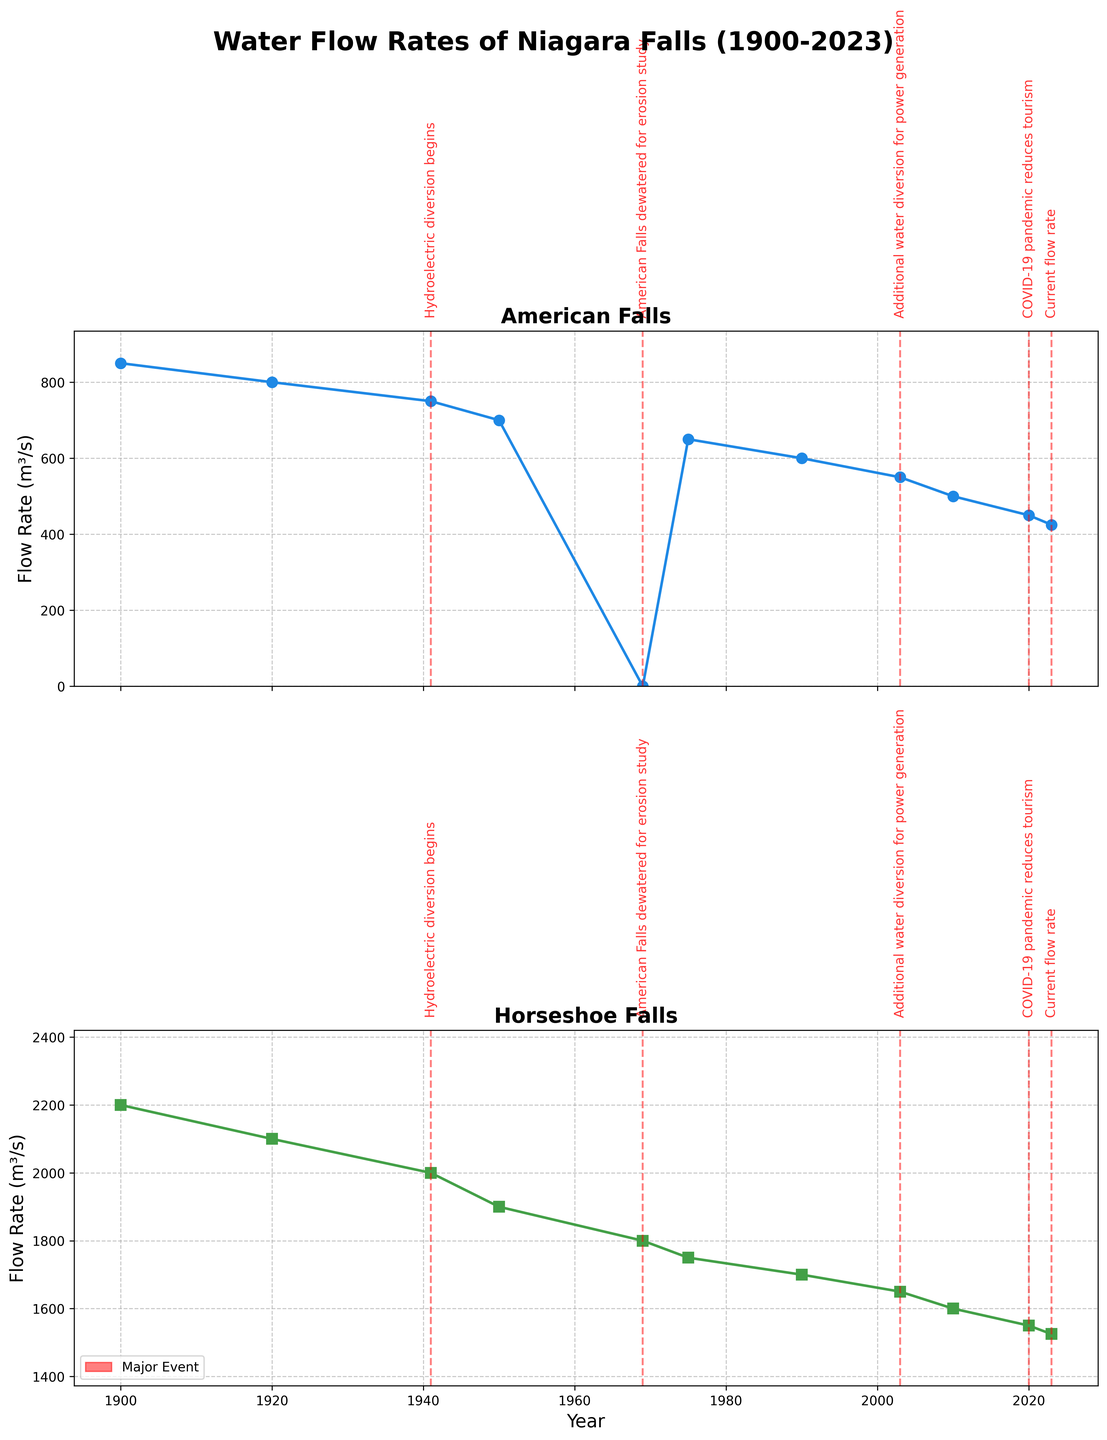What is the title of the figure? The title is usually found at the top of the figure. In this case, it's "Water Flow Rates of Niagara Falls (1900-2023)"
Answer: Water Flow Rates of Niagara Falls (1900-2023) Around what year did the American Falls have the lowest flow rate? Observing the plot for the American Falls, the lowest flow rate appears around the years 1969 and 2023, specifically during the "American Falls dewatered for erosion study" event in 1969 with a flow rate of 0 m³/s.
Answer: 1969 How many events are marked on the plots? Count the number of vertical red dashed lines on both subplots. These indicate events. There are 4 events marked.
Answer: 4 What event occurred in 1969, and how is it visually represented in the plots? In 1969, the "American Falls dewatered for erosion study" event occurred. It is represented by a vertical red dashed line and an annotation on the plot.
Answer: American Falls dewatered for erosion study Compare the flow rates of the American Falls and Horseshoe Falls in 2023. Locate the year 2023 on both plots, and compare the flow rates indicated for both falls. The American Falls has a flow rate of 425 m³/s, and the Horseshoe Falls has a flow rate of 1525 m³/s.
Answer: American Falls: 425 m³/s, Horseshoe Falls: 1525 m³/s What major event led to a significant reduction in the flow rate of the American Falls near the year 1941? Identify the annotation near the year 1941 on the plot for the American Falls, which indicates "Hydroelectric diversion begins."
Answer: Hydroelectric diversion begins What is the approximate difference in flow rates between the American Falls and the Horseshoe Falls in the year 2003? In the plots, find the flow rates for the year 2003. The American Falls has a flow rate of 550 m³/s, and the Horseshoe Falls has a flow rate of 1650 m³/s. The difference is 1650 - 550 = 1100 m³/s.
Answer: 1100 m³/s What trend can be observed in the flow rates of the American Falls over the century from 1900 to 2023? By examining the plot for the American Falls, it is clear that there is a general trend of decreasing flow rates from 850 m³/s in 1900 to about 425 m³/s in 2023.
Answer: Decreasing trend Which period had a higher flow rate for the Horseshoe Falls: 1900-2000 or 2000-2023? Calculate the average flow rates for both periods by averaging the data points for each period. For 1900-2000, the average is (2200 + 2100 + 2000 + 1900 + 1800 + 1750 + 1700) / 7 ≈ 1921.43 m³/s. For 2000-2023, the average is (1650 + 1600 + 1550 + 1525) / 4 ≈ 1581.25 m³/s. The period 1900-2000 has a higher average flow rate.
Answer: 1900-2000 What does the annotation for the year 2020 indicate, and how did it impact the flow rates? The annotation for the year 2020 indicates "COVID-19 pandemic reduces tourism." This event correlates with a slight reduction in flow rate, though there is already an ongoing downward trend.
Answer: COVID-19 pandemic reduces tourism 